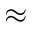Convert formula to latex. <formula><loc_0><loc_0><loc_500><loc_500>\approx</formula> 